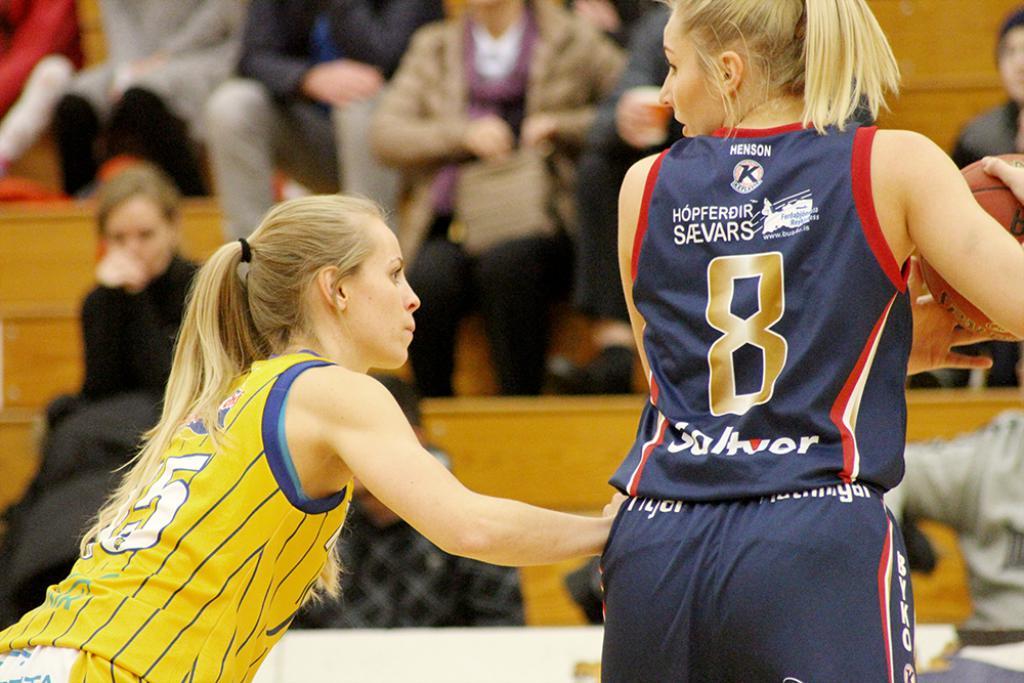What number is the player?
Provide a short and direct response. 8. Which player number is attempting to take the ball away?
Give a very brief answer. 5. 